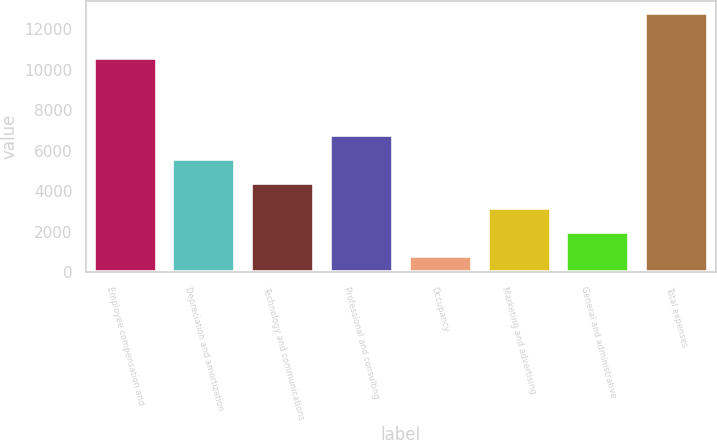Convert chart to OTSL. <chart><loc_0><loc_0><loc_500><loc_500><bar_chart><fcel>Employee compensation and<fcel>Depreciation and amortization<fcel>Technology and communications<fcel>Professional and consulting<fcel>Occupancy<fcel>Marketing and advertising<fcel>General and administrative<fcel>Total expenses<nl><fcel>10589<fcel>5589.2<fcel>4389.9<fcel>6788.5<fcel>792<fcel>3190.6<fcel>1991.3<fcel>12785<nl></chart> 